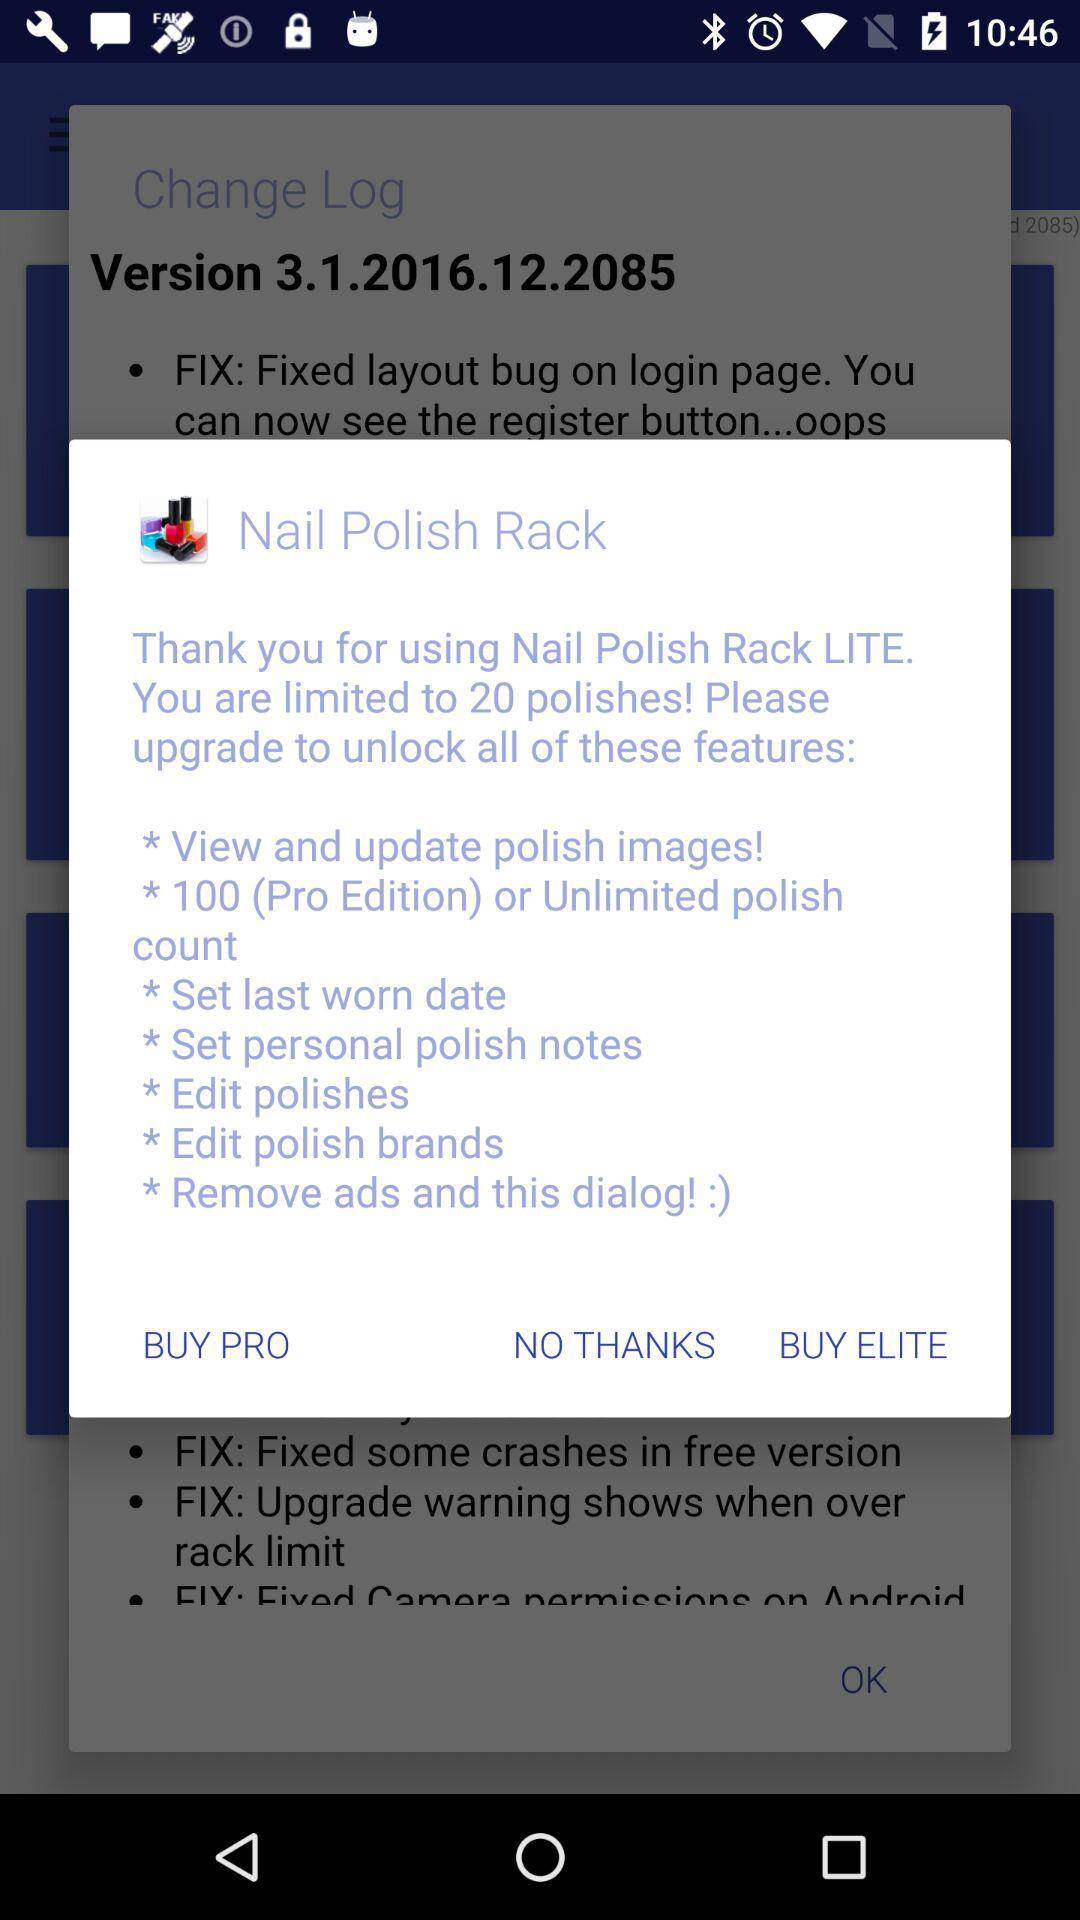How many polishes are you limited to? You are limited to 20 polishes. 